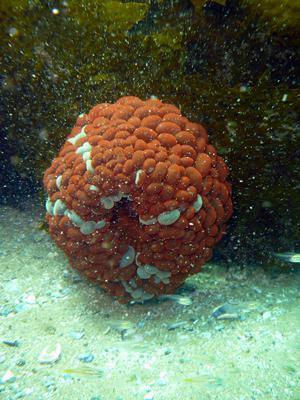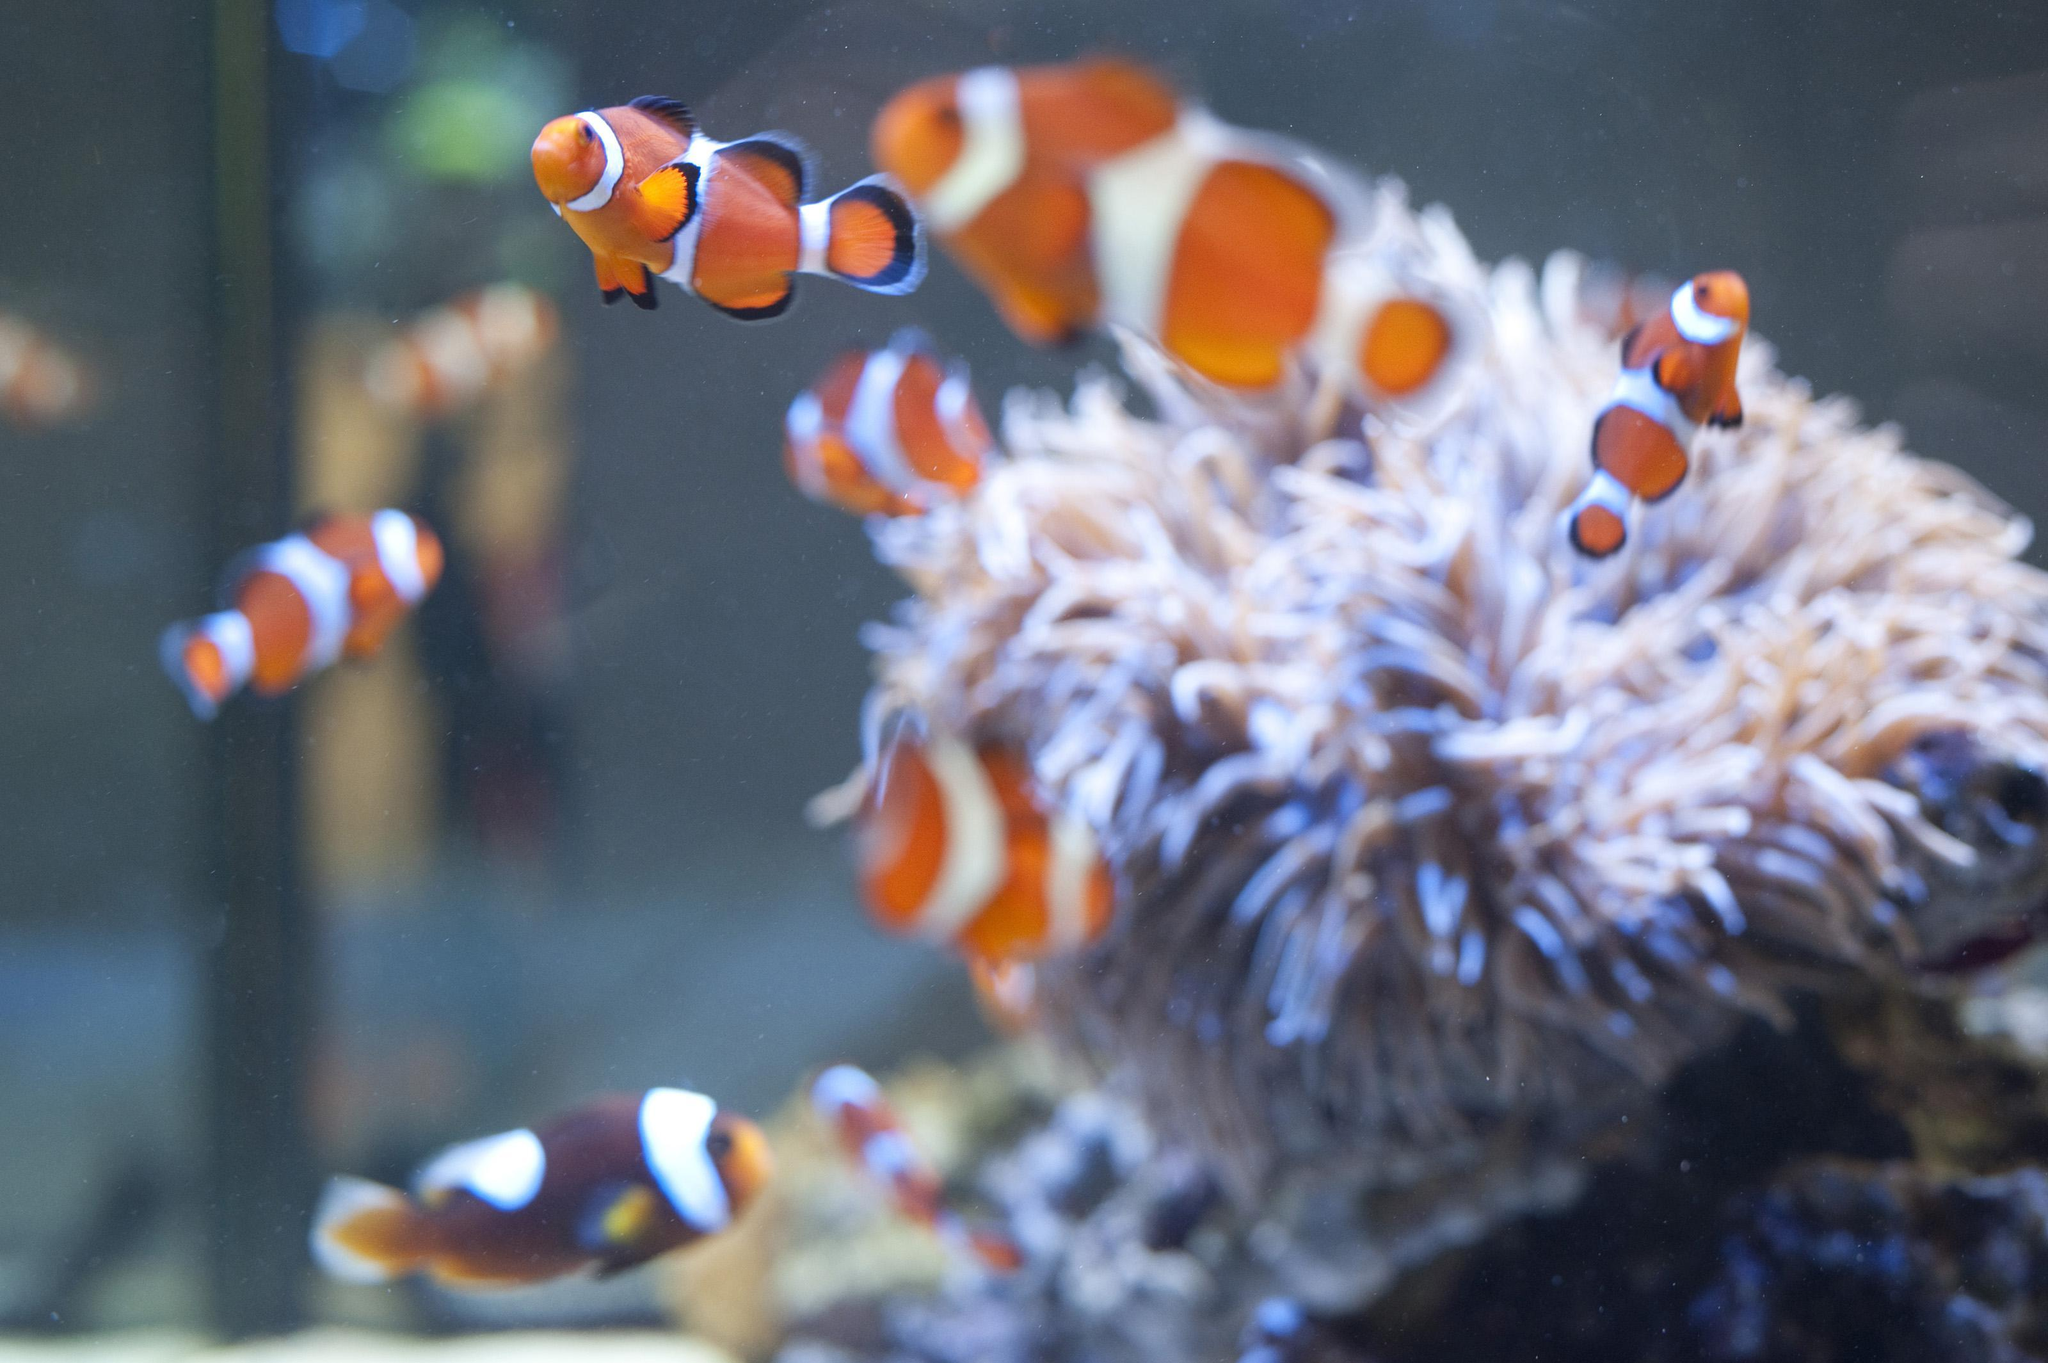The first image is the image on the left, the second image is the image on the right. For the images shown, is this caption "An image contains at least three clown fish." true? Answer yes or no. Yes. The first image is the image on the left, the second image is the image on the right. Given the left and right images, does the statement "Several fish are swimming in one of the images." hold true? Answer yes or no. Yes. 